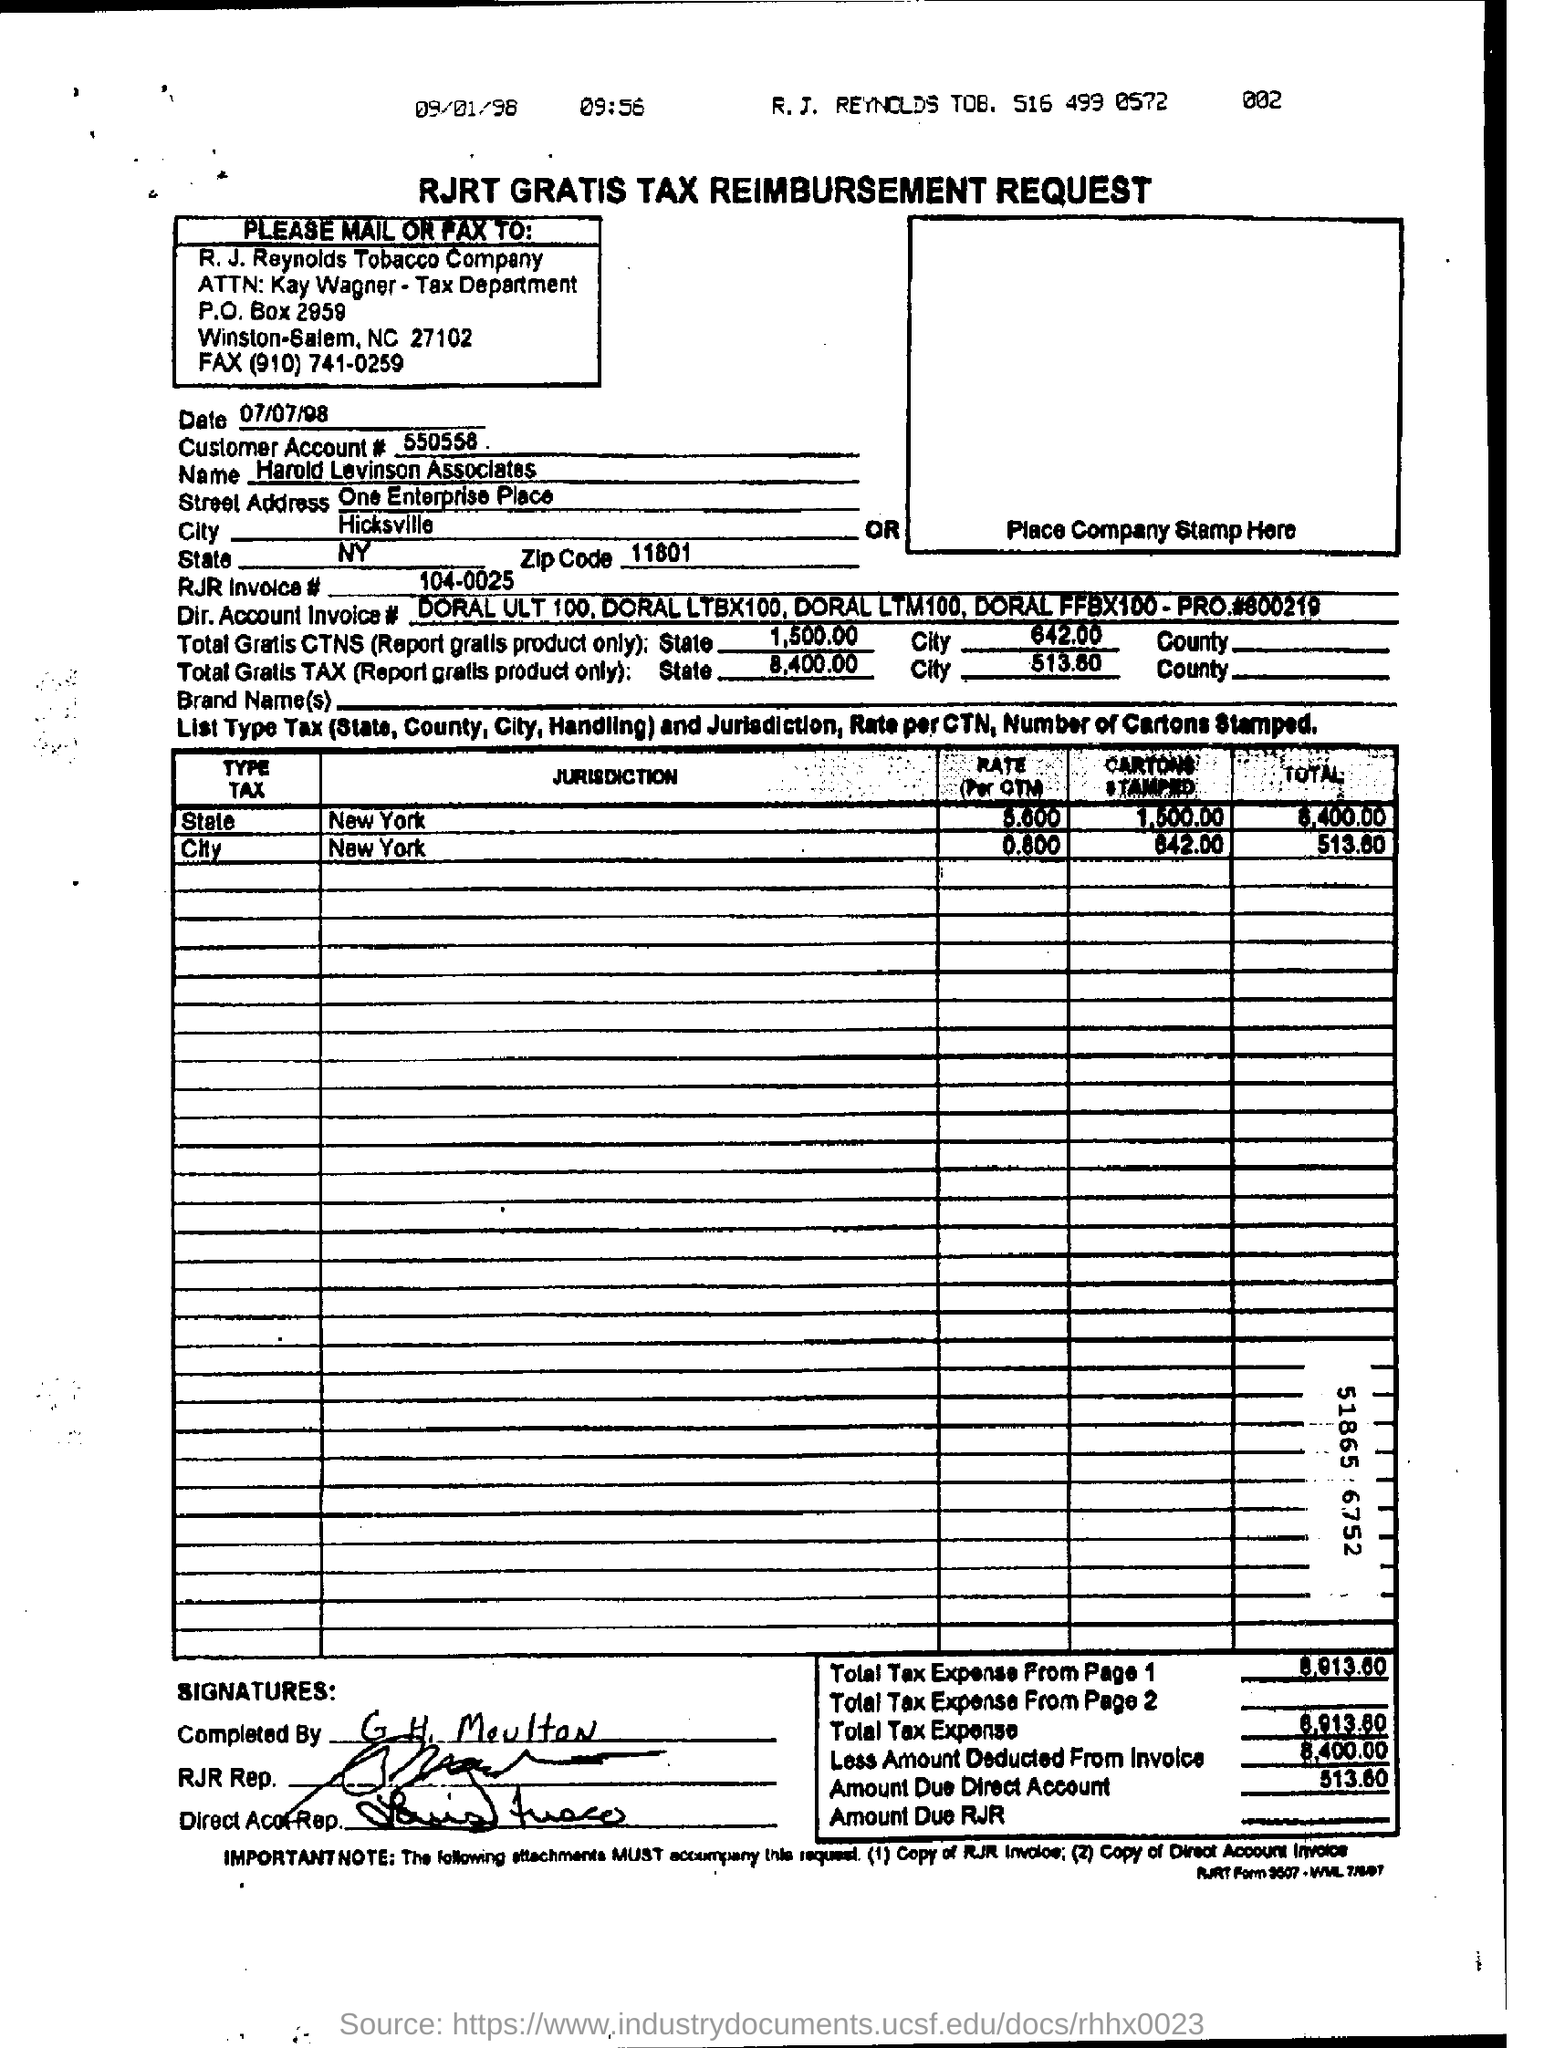How much is the amount due to direct account ?
Keep it short and to the point. 513.60. What is the street address of harold levinson associates ?
Make the answer very short. One enterprise place. 